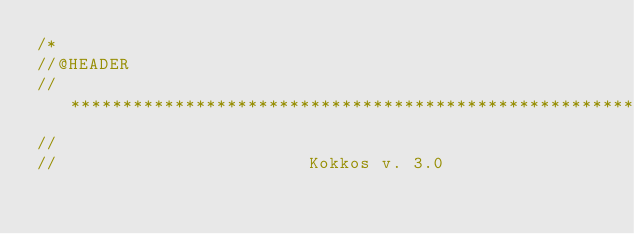Convert code to text. <code><loc_0><loc_0><loc_500><loc_500><_C++_>/*
//@HEADER
// ************************************************************************
//
//                        Kokkos v. 3.0</code> 